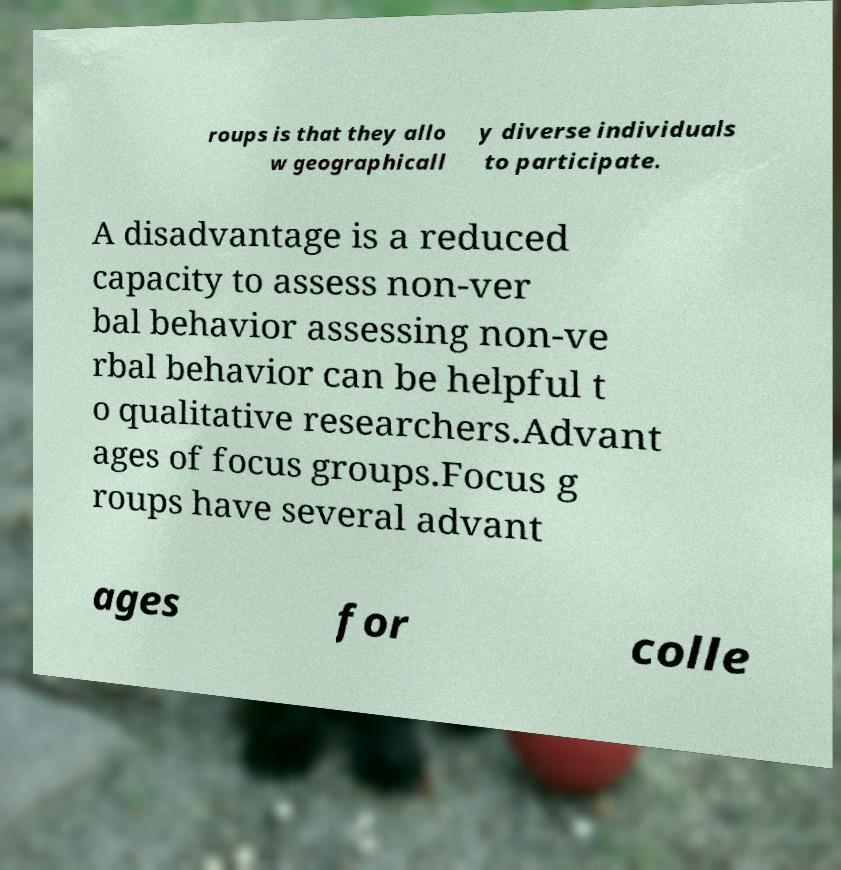Please read and relay the text visible in this image. What does it say? roups is that they allo w geographicall y diverse individuals to participate. A disadvantage is a reduced capacity to assess non-ver bal behavior assessing non-ve rbal behavior can be helpful t o qualitative researchers.Advant ages of focus groups.Focus g roups have several advant ages for colle 